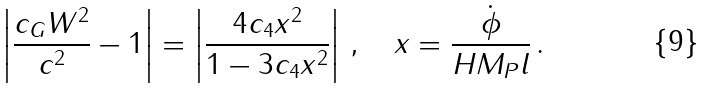Convert formula to latex. <formula><loc_0><loc_0><loc_500><loc_500>\left | \frac { c _ { G } W ^ { 2 } } { c ^ { 2 } } - 1 \right | = \left | \frac { 4 c _ { 4 } x ^ { 2 } } { 1 - 3 c _ { 4 } x ^ { 2 } } \right | \, , \quad x = \frac { \dot { \phi } } { H M _ { P } l } \, .</formula> 